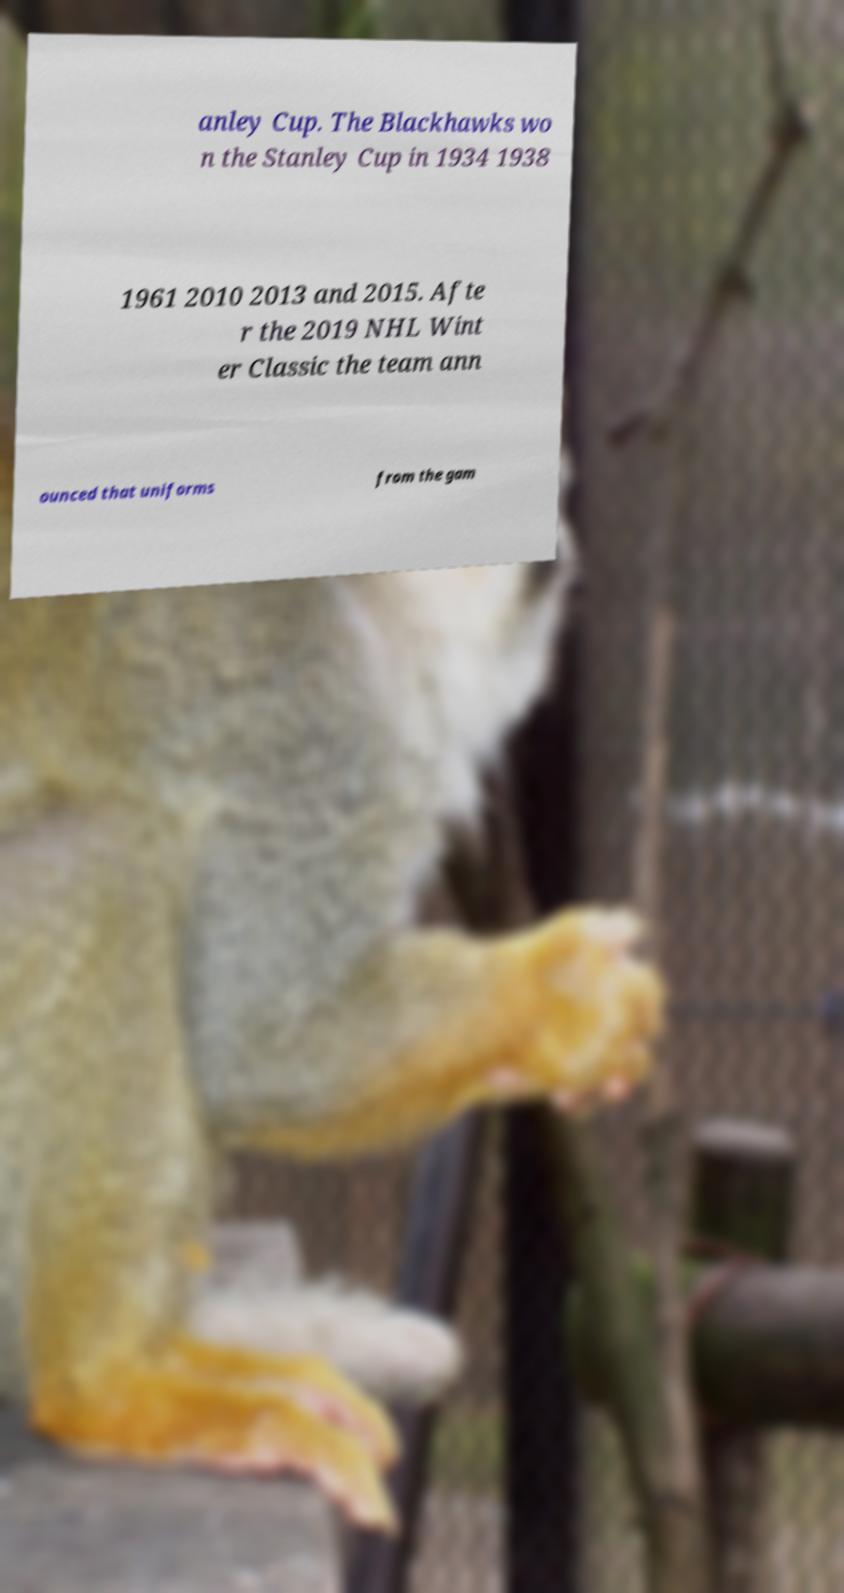Please read and relay the text visible in this image. What does it say? anley Cup. The Blackhawks wo n the Stanley Cup in 1934 1938 1961 2010 2013 and 2015. Afte r the 2019 NHL Wint er Classic the team ann ounced that uniforms from the gam 